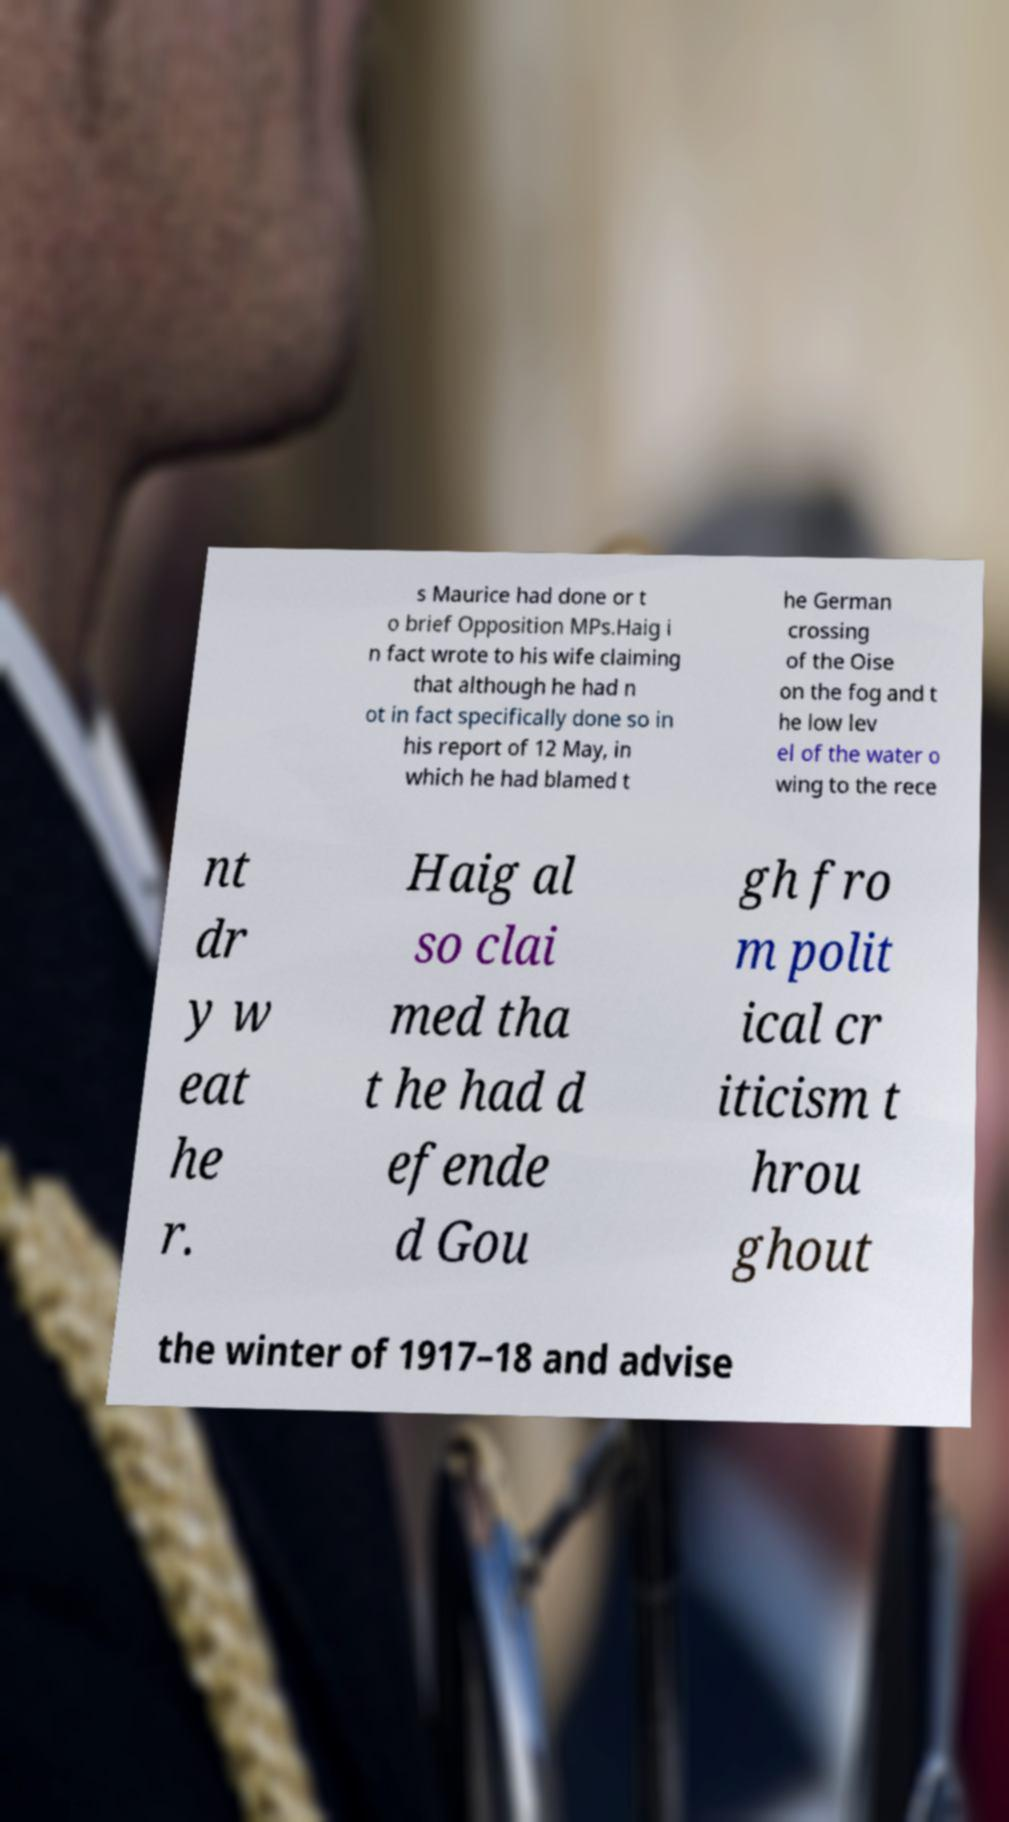Can you read and provide the text displayed in the image?This photo seems to have some interesting text. Can you extract and type it out for me? s Maurice had done or t o brief Opposition MPs.Haig i n fact wrote to his wife claiming that although he had n ot in fact specifically done so in his report of 12 May, in which he had blamed t he German crossing of the Oise on the fog and t he low lev el of the water o wing to the rece nt dr y w eat he r. Haig al so clai med tha t he had d efende d Gou gh fro m polit ical cr iticism t hrou ghout the winter of 1917–18 and advise 